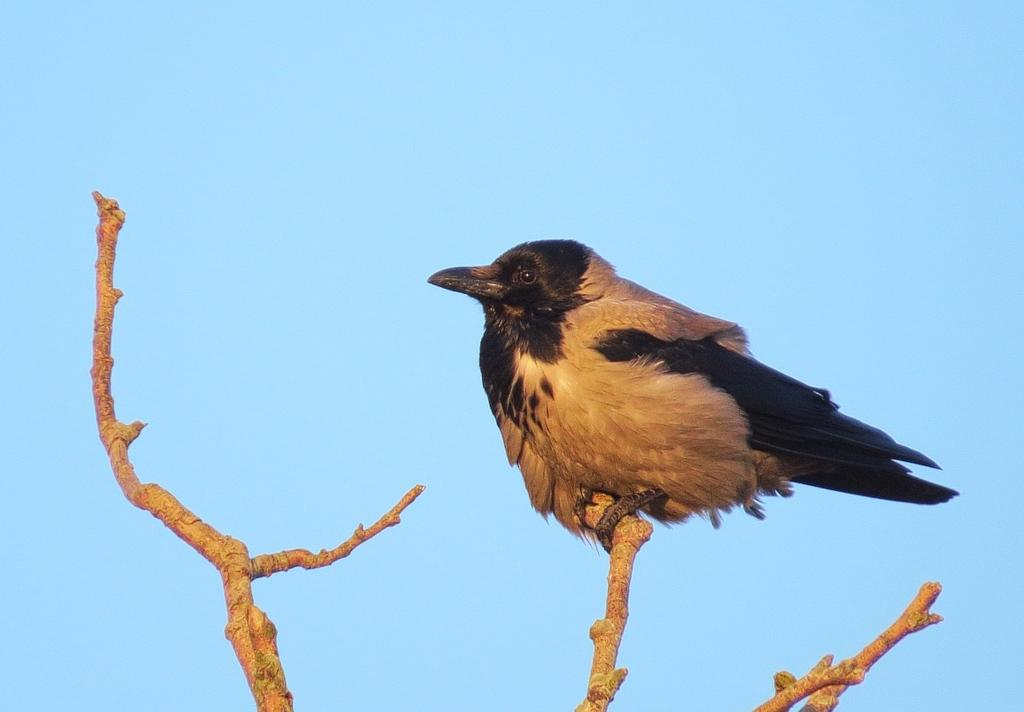What objects are made of wood in the image? There are wooden sticks in the image. What type of animal can be seen in the image? There is a bird in the image. What part of the natural environment is visible in the image? The sky is visible in the image. What color is the bird's toe in the image? There is no mention of a bird's toe in the image, and therefore no color can be determined. 